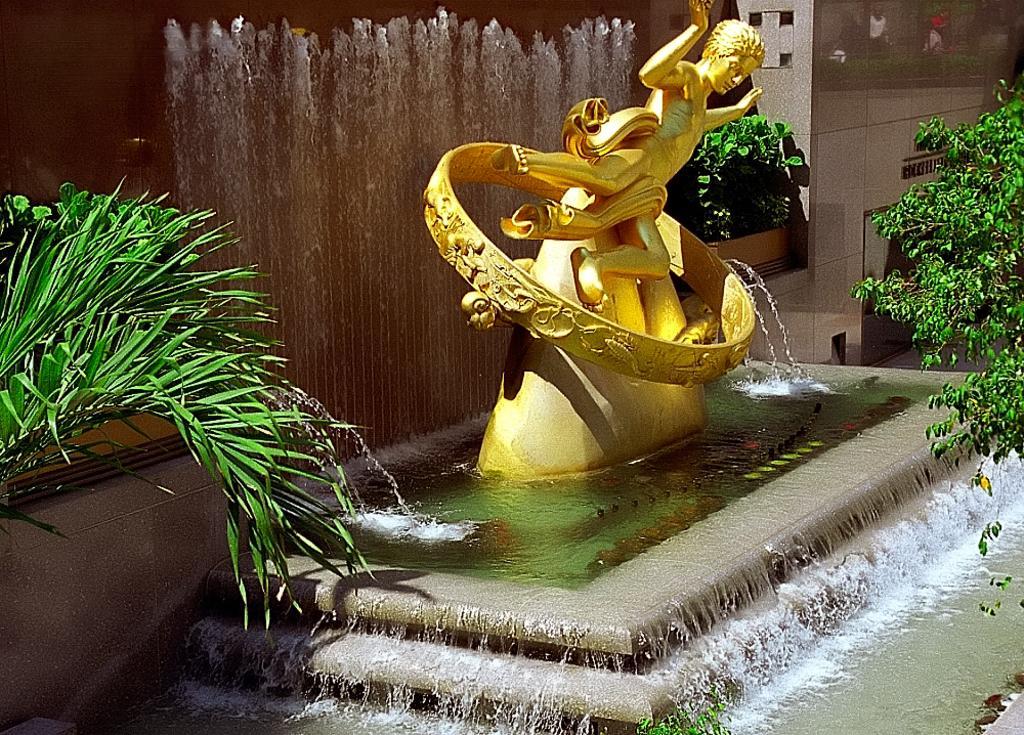Please provide a concise description of this image. In this image I can see a golden colour sculpture in the centre and around it I can see water. I can also see few plants on the both side and in the background of this image. 